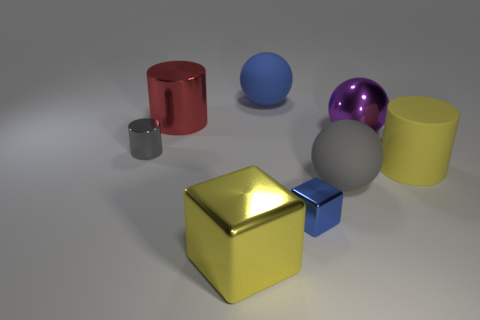Subtract all matte spheres. How many spheres are left? 1 Subtract all yellow blocks. How many blocks are left? 1 Subtract all spheres. How many objects are left? 5 Add 1 big red cylinders. How many objects exist? 9 Subtract 2 spheres. How many spheres are left? 1 Subtract all brown balls. Subtract all blue blocks. How many balls are left? 3 Add 8 large brown matte cubes. How many large brown matte cubes exist? 8 Subtract 0 cyan cylinders. How many objects are left? 8 Subtract all red cylinders. How many purple spheres are left? 1 Subtract all red shiny things. Subtract all gray things. How many objects are left? 5 